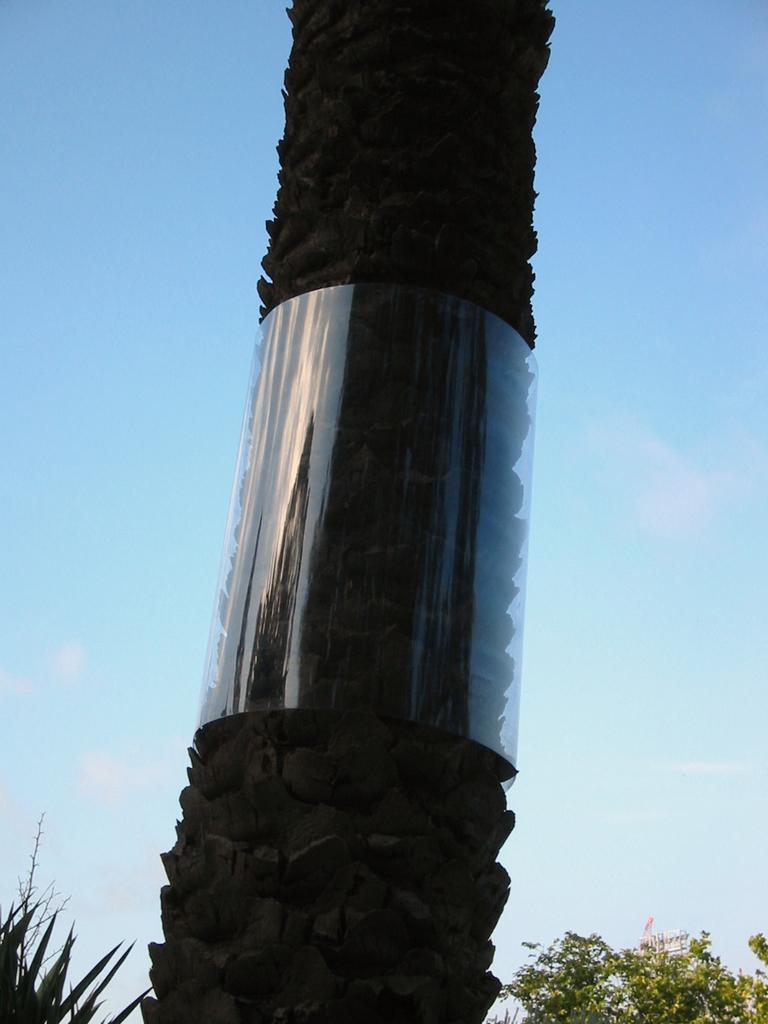In one or two sentences, can you explain what this image depicts? In this picture we can see few trees and clouds. 